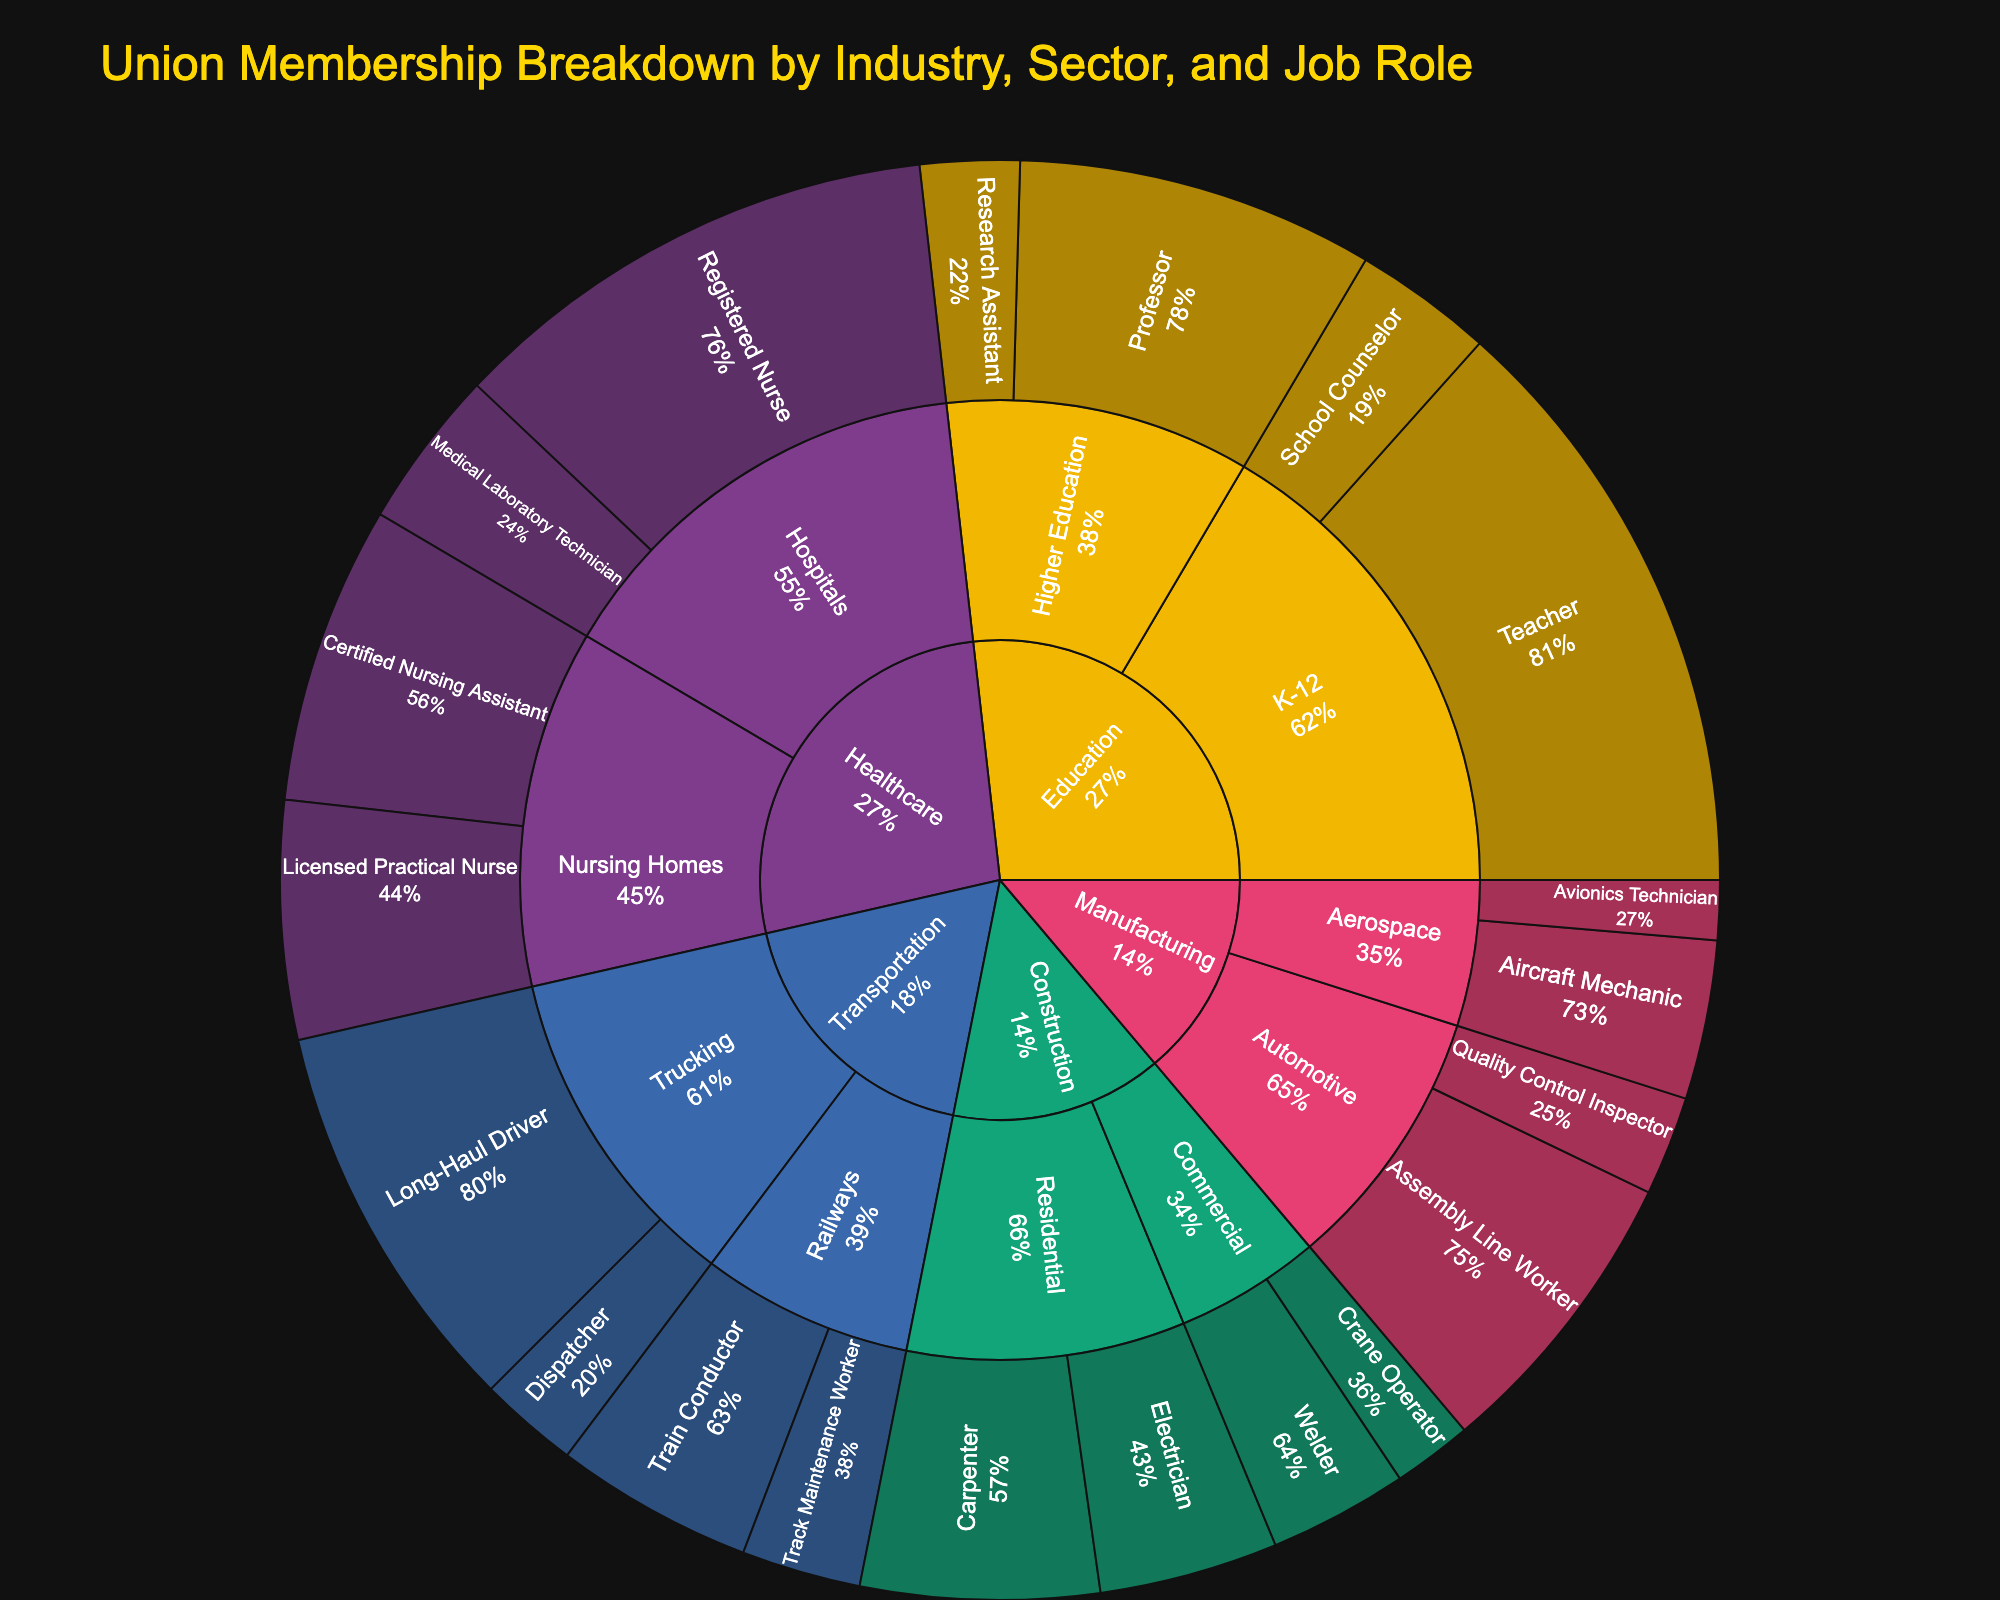What is the title of the plot? The title of the plot is prominently displayed at the top. It should give a clear indication of the content of the figure.
Answer: Union Membership Breakdown by Industry, Sector, and Job Role In which industry is the job role "Registered Nurse" found? The job roles are nested under sectors and industries, and you can find the job role "Registered Nurse" by tracing from the inner to the outer circles.
Answer: Healthcare Which sector within Construction has higher total membership, Residential or Commercial? To determine this, sum the membership values for all job roles within each sector and compare. Residential has "Carpenter" and "Electrician," while Commercial has "Welder" and "Crane Operator." The membership for Residential is 12,000 + 9,000 = 21,000 and for Commercial is 7,000 + 4,000 = 11,000.
Answer: Residential What percentage of the Manufacturing industry does the "Automotive" sector make up in terms of membership? First, sum the membership values for all job roles in the Manufacturing industry to get the total. Then find the sum of membership values for all job roles in the Automotive sector. Divide the Automotive total by the Manufacturing total and convert it to a percentage. Manufacturing total is 15,000 + 5,000 + 8,000 + 3,000 = 31,000. Automotive is 15,000 + 5,000 = 20,000. So, (20,000 / 31,000) * 100 ≈ 64.5%.
Answer: 64.5% Which job role in the Transportation industry has the highest membership? By examining the segments under the Transportation industry slice, identify the job role with the largest numerical value.
Answer: Long-Haul Driver What is the total membership for the Education industry? Add the membership values for all job roles within the Education industry. These include Teacher (30,000), School Counselor (7,000), Professor (18,000), and Research Assistant (5,000). The total is 30,000 + 7,000 + 18,000 + 5,000 = 60,000.
Answer: 60,000 How does the membership for "Certified Nursing Assistant" compare to "Long-Haul Driver"? Locate the membership values for both "Certified Nursing Assistant" and "Long-Haul Driver." Certified Nursing Assistant has 15,000 members, while Long-Haul Driver has 20,000 members. Compare the two values directly.
Answer: Long-Haul Driver is higher What job roles fall under the Automotive sector? By identifying the section of the plot corresponding to the Automotive sector, list the job roles displayed.
Answer: Assembly Line Worker, Quality Control Inspector Which job role within the Healthcare industry has the fewest members? Look at the job roles nested under Healthcare and find the one with the smallest numerical membership value.
Answer: Medical Laboratory Technician 